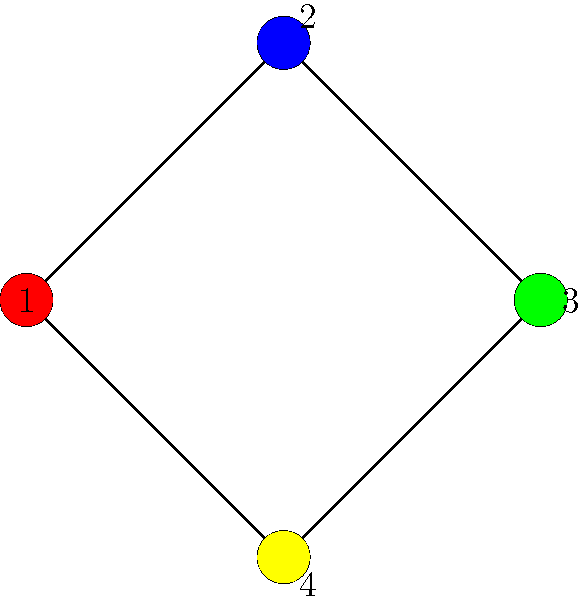Consider a molecule with four atomic orbitals represented by the vertices of the graph above. Each color represents a different energy level. How many electrons can be accommodated in this molecular orbital configuration according to graph coloring principles, assuming each orbital can hold up to two electrons of opposite spins? To solve this problem, we need to follow these steps:

1. Understand the graph coloring representation:
   - Each vertex represents an atomic orbital.
   - Each color represents a different energy level.
   - The graph uses four different colors (red, blue, green, yellow).

2. Apply the Pauli exclusion principle:
   - Each orbital (vertex) can hold up to two electrons with opposite spins.

3. Count the number of colored vertices:
   - There are four vertices, each with a unique color.

4. Calculate the total number of electrons:
   - For each colored vertex (orbital), we can accommodate 2 electrons.
   - Total number of electrons = Number of vertices × 2
   - Total number of electrons = 4 × 2 = 8

5. Verify the result:
   - This configuration allows for maximum occupancy while maintaining different energy levels for each orbital, which is consistent with molecular orbital theory.
Answer: 8 electrons 